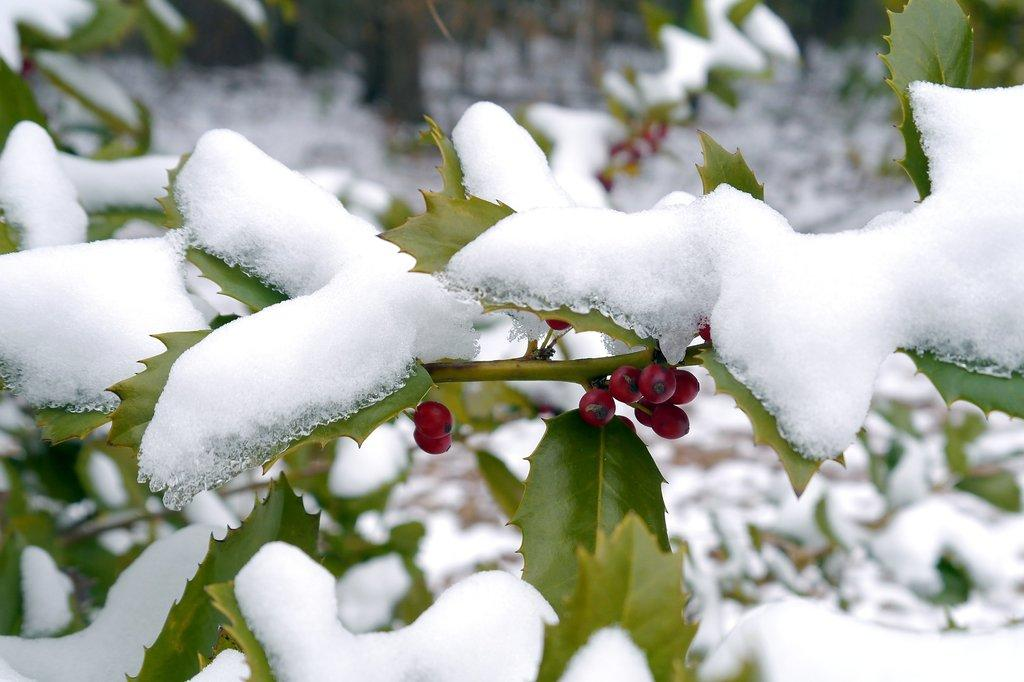What color can be seen on objects in the image? There are red color things in the image. What type of vegetation is present in the image? There are green leaves in the image. What is the condition of the leaves in the image? Snow is visible on the leaves. How would you describe the overall clarity of the image? The image is slightly blurry in the background. What is the belief system of the earth in the image? There is no reference to a belief system or the earth in the image, so it is not possible to answer that question. 